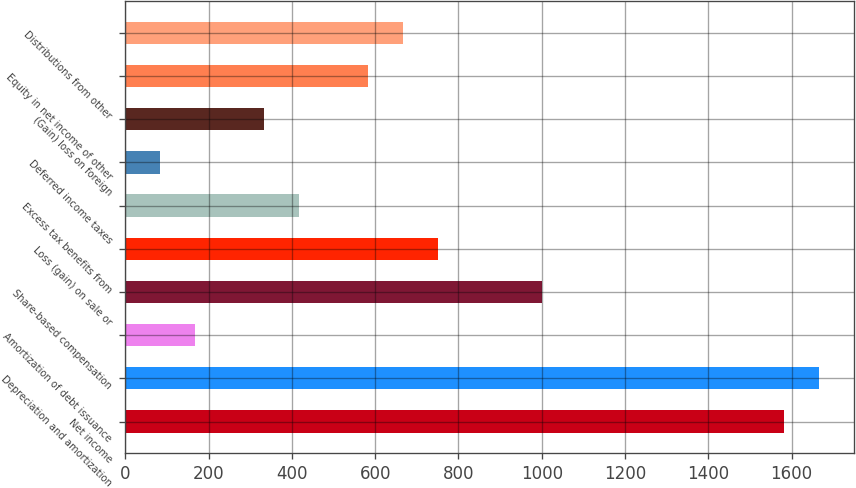Convert chart. <chart><loc_0><loc_0><loc_500><loc_500><bar_chart><fcel>Net income<fcel>Depreciation and amortization<fcel>Amortization of debt issuance<fcel>Share-based compensation<fcel>Loss (gain) on sale or<fcel>Excess tax benefits from<fcel>Deferred income taxes<fcel>(Gain) loss on foreign<fcel>Equity in net income of other<fcel>Distributions from other<nl><fcel>1582.81<fcel>1666.1<fcel>166.88<fcel>999.78<fcel>749.91<fcel>416.75<fcel>83.59<fcel>333.46<fcel>583.33<fcel>666.62<nl></chart> 